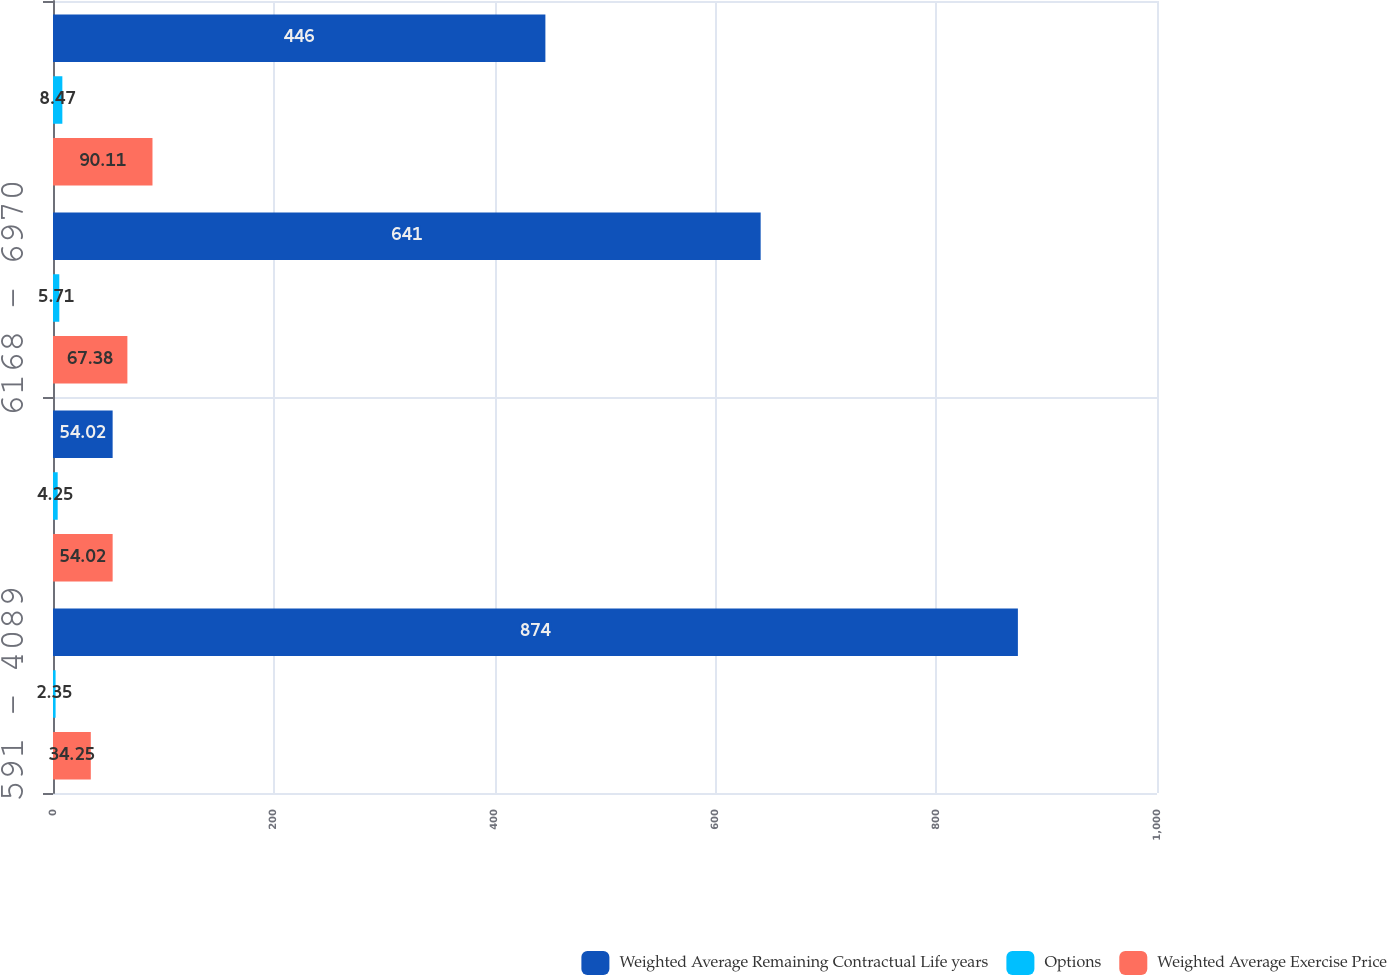Convert chart to OTSL. <chart><loc_0><loc_0><loc_500><loc_500><stacked_bar_chart><ecel><fcel>591 - 4089<fcel>4133 - 5867<fcel>6168 - 6970<fcel>7345 - 9509<nl><fcel>Weighted Average Remaining Contractual Life years<fcel>874<fcel>54.02<fcel>641<fcel>446<nl><fcel>Options<fcel>2.35<fcel>4.25<fcel>5.71<fcel>8.47<nl><fcel>Weighted Average Exercise Price<fcel>34.25<fcel>54.02<fcel>67.38<fcel>90.11<nl></chart> 